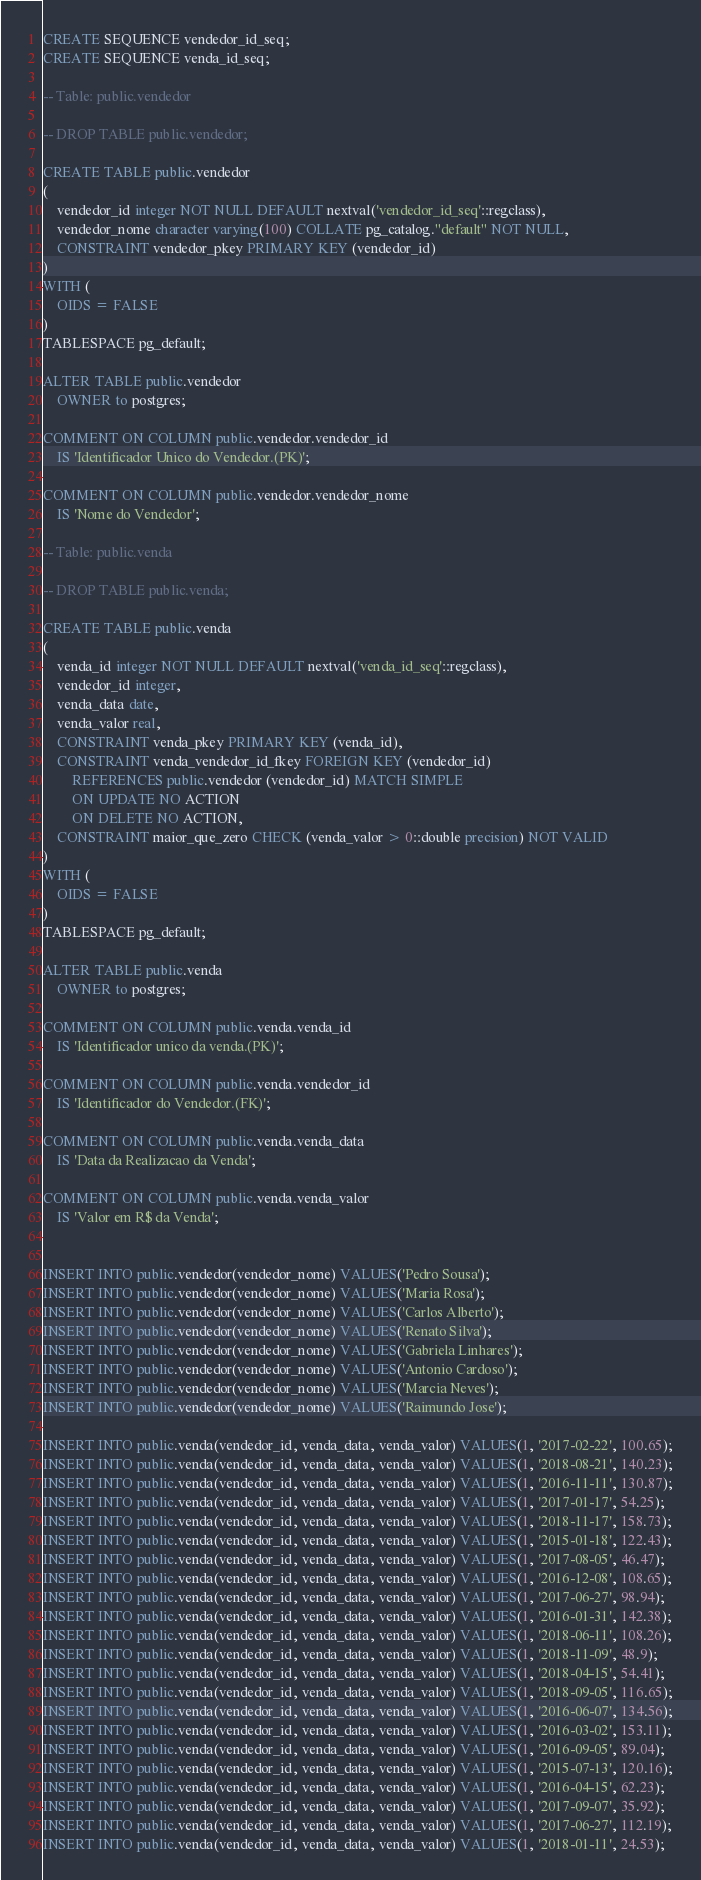<code> <loc_0><loc_0><loc_500><loc_500><_SQL_>CREATE SEQUENCE vendedor_id_seq;
CREATE SEQUENCE venda_id_seq;

-- Table: public.vendedor

-- DROP TABLE public.vendedor;

CREATE TABLE public.vendedor
(
    vendedor_id integer NOT NULL DEFAULT nextval('vendedor_id_seq'::regclass),
    vendedor_nome character varying(100) COLLATE pg_catalog."default" NOT NULL,
    CONSTRAINT vendedor_pkey PRIMARY KEY (vendedor_id)
)
WITH (
    OIDS = FALSE
)
TABLESPACE pg_default;

ALTER TABLE public.vendedor
    OWNER to postgres;

COMMENT ON COLUMN public.vendedor.vendedor_id
    IS 'Identificador Unico do Vendedor.(PK)';

COMMENT ON COLUMN public.vendedor.vendedor_nome
    IS 'Nome do Vendedor';

-- Table: public.venda

-- DROP TABLE public.venda;

CREATE TABLE public.venda
(
    venda_id integer NOT NULL DEFAULT nextval('venda_id_seq'::regclass),
    vendedor_id integer,
    venda_data date,
    venda_valor real,
    CONSTRAINT venda_pkey PRIMARY KEY (venda_id),
    CONSTRAINT venda_vendedor_id_fkey FOREIGN KEY (vendedor_id)
        REFERENCES public.vendedor (vendedor_id) MATCH SIMPLE
        ON UPDATE NO ACTION
        ON DELETE NO ACTION,
    CONSTRAINT maior_que_zero CHECK (venda_valor > 0::double precision) NOT VALID
)
WITH (
    OIDS = FALSE
)
TABLESPACE pg_default;

ALTER TABLE public.venda
    OWNER to postgres;

COMMENT ON COLUMN public.venda.venda_id
    IS 'Identificador unico da venda.(PK)';

COMMENT ON COLUMN public.venda.vendedor_id
    IS 'Identificador do Vendedor.(FK)';

COMMENT ON COLUMN public.venda.venda_data
    IS 'Data da Realizacao da Venda';

COMMENT ON COLUMN public.venda.venda_valor
    IS 'Valor em R$ da Venda';


INSERT INTO public.vendedor(vendedor_nome) VALUES('Pedro Sousa');
INSERT INTO public.vendedor(vendedor_nome) VALUES('Maria Rosa');
INSERT INTO public.vendedor(vendedor_nome) VALUES('Carlos Alberto');
INSERT INTO public.vendedor(vendedor_nome) VALUES('Renato Silva');
INSERT INTO public.vendedor(vendedor_nome) VALUES('Gabriela Linhares');
INSERT INTO public.vendedor(vendedor_nome) VALUES('Antonio Cardoso');
INSERT INTO public.vendedor(vendedor_nome) VALUES('Marcia Neves');
INSERT INTO public.vendedor(vendedor_nome) VALUES('Raimundo Jose');

INSERT INTO public.venda(vendedor_id, venda_data, venda_valor) VALUES(1, '2017-02-22', 100.65);
INSERT INTO public.venda(vendedor_id, venda_data, venda_valor) VALUES(1, '2018-08-21', 140.23);
INSERT INTO public.venda(vendedor_id, venda_data, venda_valor) VALUES(1, '2016-11-11', 130.87);
INSERT INTO public.venda(vendedor_id, venda_data, venda_valor) VALUES(1, '2017-01-17', 54.25);
INSERT INTO public.venda(vendedor_id, venda_data, venda_valor) VALUES(1, '2018-11-17', 158.73);
INSERT INTO public.venda(vendedor_id, venda_data, venda_valor) VALUES(1, '2015-01-18', 122.43);
INSERT INTO public.venda(vendedor_id, venda_data, venda_valor) VALUES(1, '2017-08-05', 46.47);
INSERT INTO public.venda(vendedor_id, venda_data, venda_valor) VALUES(1, '2016-12-08', 108.65);
INSERT INTO public.venda(vendedor_id, venda_data, venda_valor) VALUES(1, '2017-06-27', 98.94);
INSERT INTO public.venda(vendedor_id, venda_data, venda_valor) VALUES(1, '2016-01-31', 142.38);
INSERT INTO public.venda(vendedor_id, venda_data, venda_valor) VALUES(1, '2018-06-11', 108.26);
INSERT INTO public.venda(vendedor_id, venda_data, venda_valor) VALUES(1, '2018-11-09', 48.9);
INSERT INTO public.venda(vendedor_id, venda_data, venda_valor) VALUES(1, '2018-04-15', 54.41);
INSERT INTO public.venda(vendedor_id, venda_data, venda_valor) VALUES(1, '2018-09-05', 116.65);
INSERT INTO public.venda(vendedor_id, venda_data, venda_valor) VALUES(1, '2016-06-07', 134.56);
INSERT INTO public.venda(vendedor_id, venda_data, venda_valor) VALUES(1, '2016-03-02', 153.11);
INSERT INTO public.venda(vendedor_id, venda_data, venda_valor) VALUES(1, '2016-09-05', 89.04);
INSERT INTO public.venda(vendedor_id, venda_data, venda_valor) VALUES(1, '2015-07-13', 120.16);
INSERT INTO public.venda(vendedor_id, venda_data, venda_valor) VALUES(1, '2016-04-15', 62.23);
INSERT INTO public.venda(vendedor_id, venda_data, venda_valor) VALUES(1, '2017-09-07', 35.92);
INSERT INTO public.venda(vendedor_id, venda_data, venda_valor) VALUES(1, '2017-06-27', 112.19);
INSERT INTO public.venda(vendedor_id, venda_data, venda_valor) VALUES(1, '2018-01-11', 24.53);</code> 